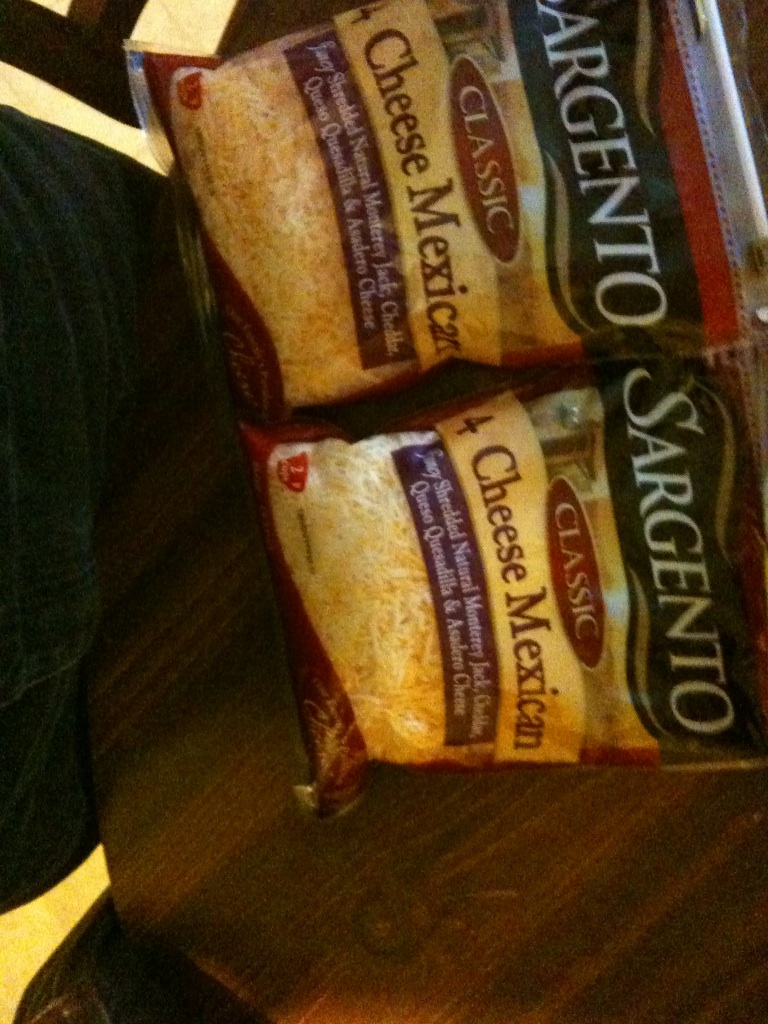How would you describe the texture and flavor of the cheeses in this blend to someone who has never tasted them? The Sargento Classic 4 Cheese Mexican blend offers a delightful mix of textures and flavors:
- **Monterey Jack:** Smooth and mild, with a creamy texture that melts beautifully, perfect for balancing stronger flavors.
- **Cheddar:** A firm and crumbly cheese with a sharp, distinctive flavor that adds a zesty bite to any dish.
- **Queso Quesadilla:** Velvety and rich, this cheese has excellent melting qualities, providing a luscious texture and a mild, buttery taste.
- **Asadero:** Soft and stringy, it is similar to mozzarella with a slightly tangy finish, making it ideal for melting and stretching in dishes like quesadillas and nachos. 